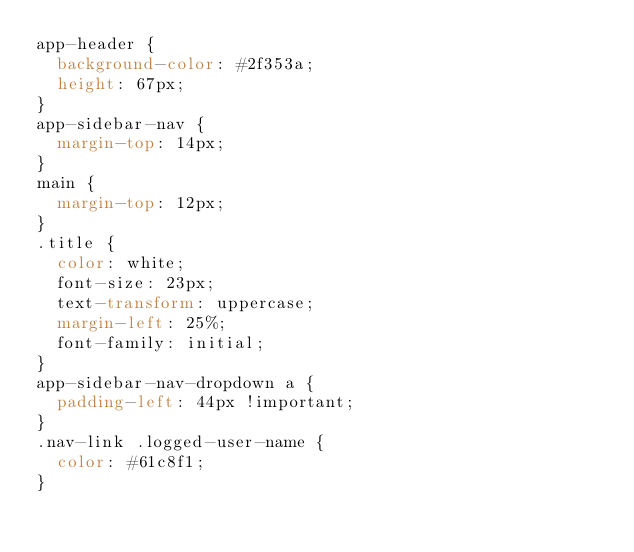<code> <loc_0><loc_0><loc_500><loc_500><_CSS_>app-header {
  background-color: #2f353a;
  height: 67px;
}
app-sidebar-nav {
  margin-top: 14px;
}
main {
  margin-top: 12px;
}
.title {
  color: white;
  font-size: 23px;
  text-transform: uppercase;
  margin-left: 25%;
  font-family: initial;
}
app-sidebar-nav-dropdown a {
  padding-left: 44px !important;
}
.nav-link .logged-user-name {
  color: #61c8f1;
}
</code> 